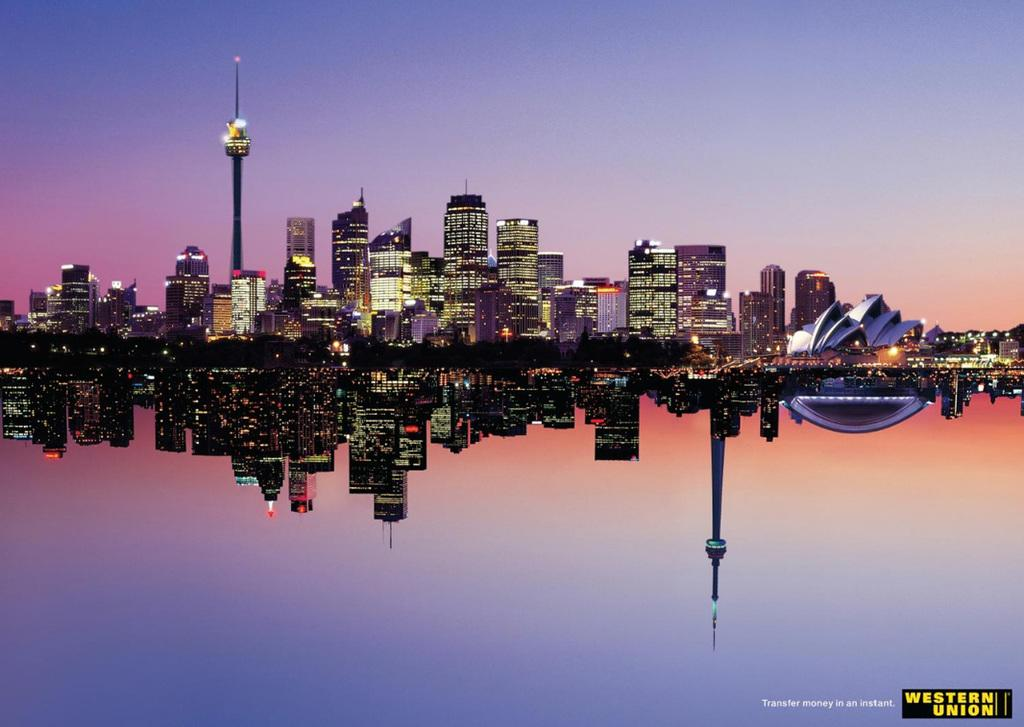What is the primary element in the image? There is water in the image. What can be seen in the background of the image? There are buildings and lights in the background of the image. What is visible in the sky in the image? The sky is visible in the background of the image. Where is the text located in the image? The text is on the right side of the image. Can you tell me how many buttons are on the tiger's body in the image? There is no tiger or buttons present in the image. 